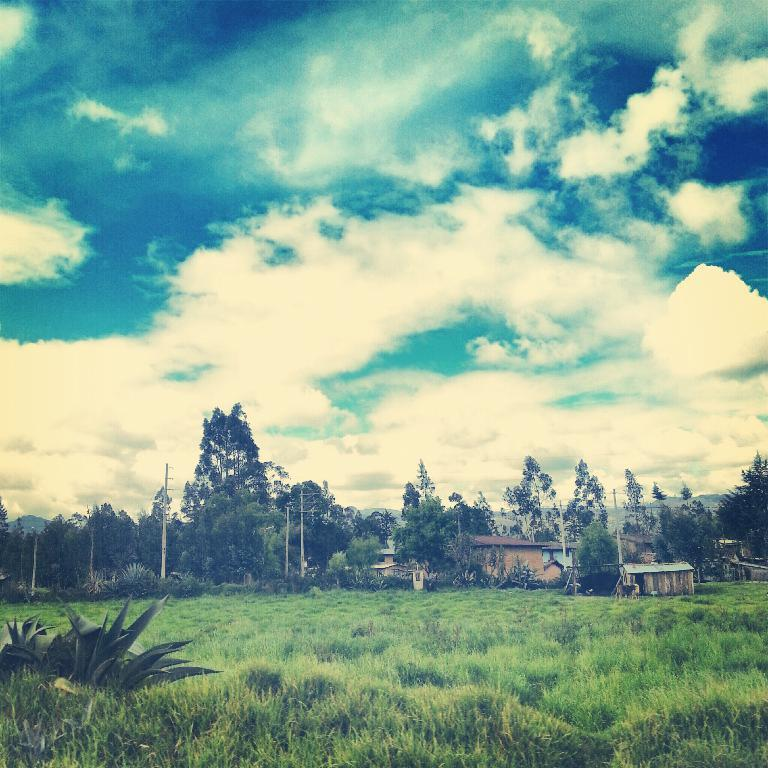What type of structures can be seen in the image? There are houses in the image. What else can be seen in the image besides houses? There are poles, objects on the ground, trees, bushes, plants, and grass visible in the image. What is visible at the top of the image? The sky is visible at the top of the image. What is the condition of the sky in the image? The sky is cloudy in the image. What type of verse can be heard recited by the plants in the image? There are no verses or sounds associated with the plants in the image; they are stationary objects. What type of food is being prepared on the ground in the image? There is no food preparation visible in the image; it only shows houses, poles, objects on the ground, trees, bushes, plants, grass, and a cloudy sky. 